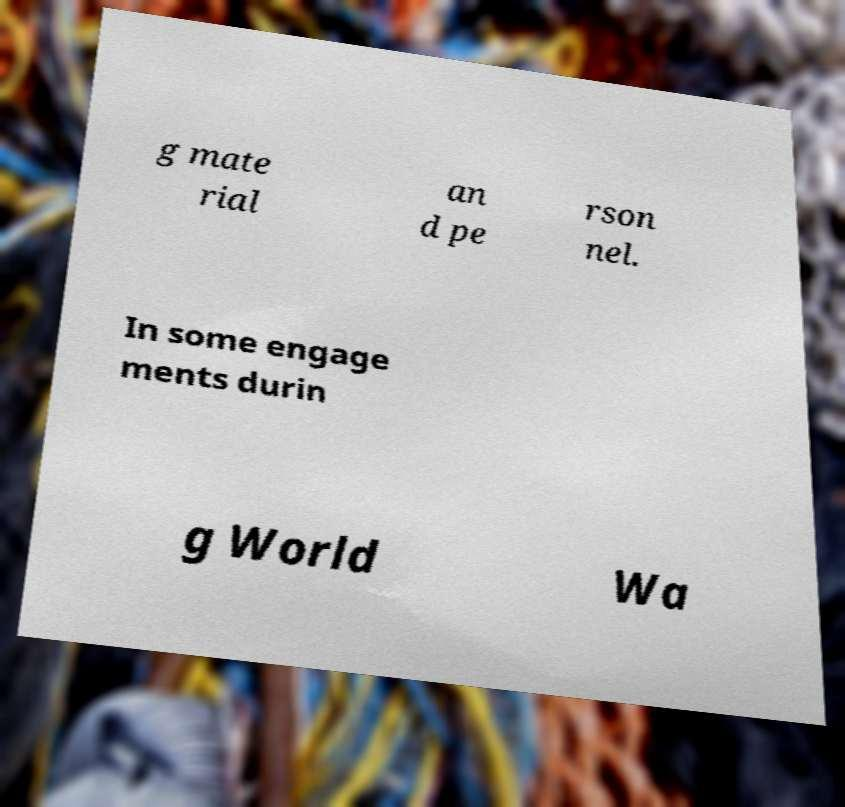Please read and relay the text visible in this image. What does it say? g mate rial an d pe rson nel. In some engage ments durin g World Wa 